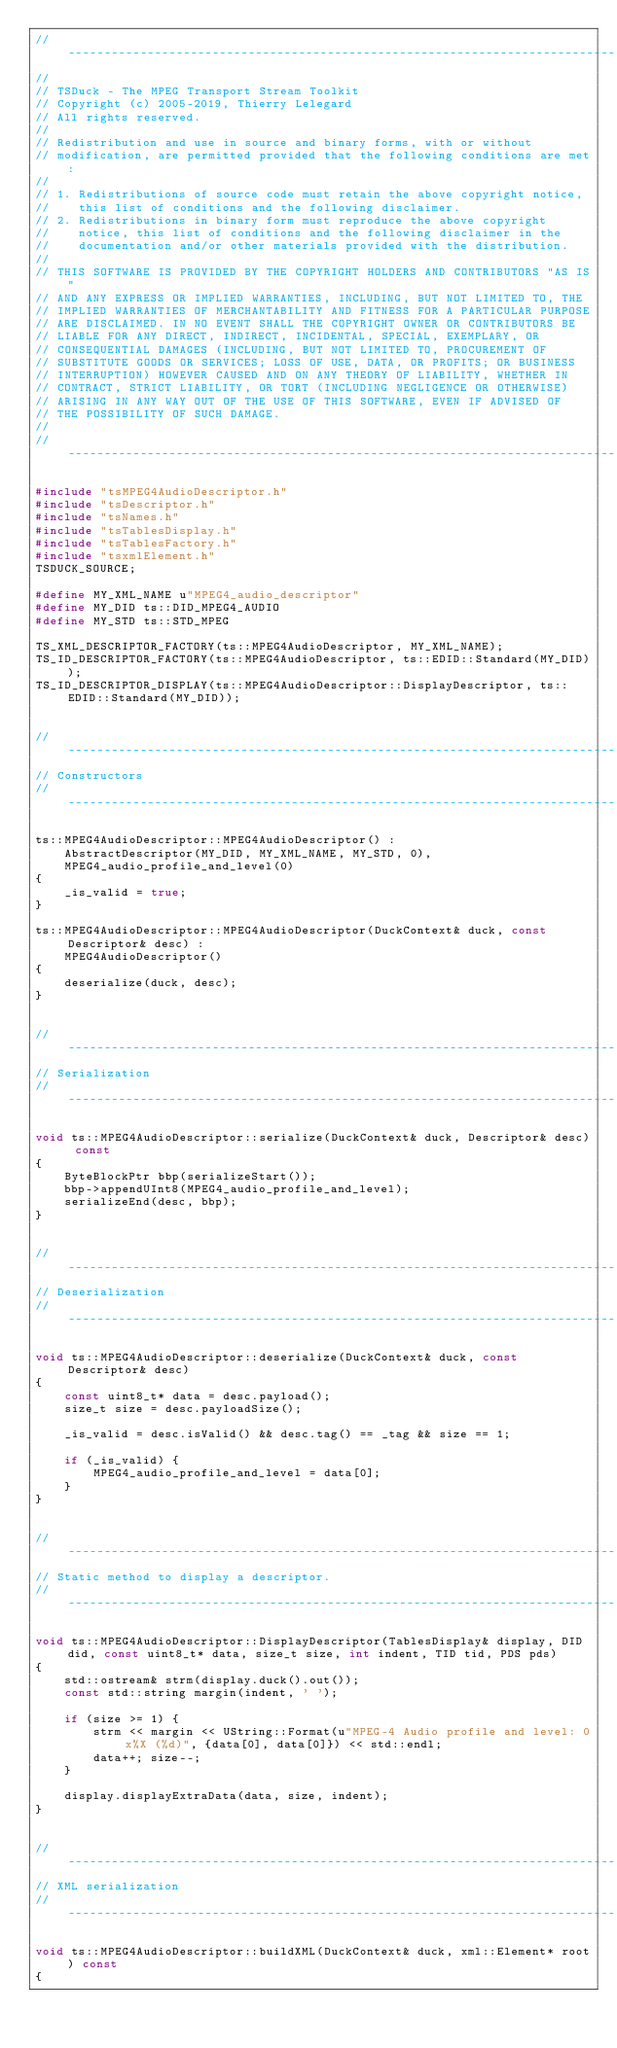<code> <loc_0><loc_0><loc_500><loc_500><_C++_>//----------------------------------------------------------------------------
//
// TSDuck - The MPEG Transport Stream Toolkit
// Copyright (c) 2005-2019, Thierry Lelegard
// All rights reserved.
//
// Redistribution and use in source and binary forms, with or without
// modification, are permitted provided that the following conditions are met:
//
// 1. Redistributions of source code must retain the above copyright notice,
//    this list of conditions and the following disclaimer.
// 2. Redistributions in binary form must reproduce the above copyright
//    notice, this list of conditions and the following disclaimer in the
//    documentation and/or other materials provided with the distribution.
//
// THIS SOFTWARE IS PROVIDED BY THE COPYRIGHT HOLDERS AND CONTRIBUTORS "AS IS"
// AND ANY EXPRESS OR IMPLIED WARRANTIES, INCLUDING, BUT NOT LIMITED TO, THE
// IMPLIED WARRANTIES OF MERCHANTABILITY AND FITNESS FOR A PARTICULAR PURPOSE
// ARE DISCLAIMED. IN NO EVENT SHALL THE COPYRIGHT OWNER OR CONTRIBUTORS BE
// LIABLE FOR ANY DIRECT, INDIRECT, INCIDENTAL, SPECIAL, EXEMPLARY, OR
// CONSEQUENTIAL DAMAGES (INCLUDING, BUT NOT LIMITED TO, PROCUREMENT OF
// SUBSTITUTE GOODS OR SERVICES; LOSS OF USE, DATA, OR PROFITS; OR BUSINESS
// INTERRUPTION) HOWEVER CAUSED AND ON ANY THEORY OF LIABILITY, WHETHER IN
// CONTRACT, STRICT LIABILITY, OR TORT (INCLUDING NEGLIGENCE OR OTHERWISE)
// ARISING IN ANY WAY OUT OF THE USE OF THIS SOFTWARE, EVEN IF ADVISED OF
// THE POSSIBILITY OF SUCH DAMAGE.
//
//----------------------------------------------------------------------------

#include "tsMPEG4AudioDescriptor.h"
#include "tsDescriptor.h"
#include "tsNames.h"
#include "tsTablesDisplay.h"
#include "tsTablesFactory.h"
#include "tsxmlElement.h"
TSDUCK_SOURCE;

#define MY_XML_NAME u"MPEG4_audio_descriptor"
#define MY_DID ts::DID_MPEG4_AUDIO
#define MY_STD ts::STD_MPEG

TS_XML_DESCRIPTOR_FACTORY(ts::MPEG4AudioDescriptor, MY_XML_NAME);
TS_ID_DESCRIPTOR_FACTORY(ts::MPEG4AudioDescriptor, ts::EDID::Standard(MY_DID));
TS_ID_DESCRIPTOR_DISPLAY(ts::MPEG4AudioDescriptor::DisplayDescriptor, ts::EDID::Standard(MY_DID));


//----------------------------------------------------------------------------
// Constructors
//----------------------------------------------------------------------------

ts::MPEG4AudioDescriptor::MPEG4AudioDescriptor() :
    AbstractDescriptor(MY_DID, MY_XML_NAME, MY_STD, 0),
    MPEG4_audio_profile_and_level(0)
{
    _is_valid = true;
}

ts::MPEG4AudioDescriptor::MPEG4AudioDescriptor(DuckContext& duck, const Descriptor& desc) :
    MPEG4AudioDescriptor()
{
    deserialize(duck, desc);
}


//----------------------------------------------------------------------------
// Serialization
//----------------------------------------------------------------------------

void ts::MPEG4AudioDescriptor::serialize(DuckContext& duck, Descriptor& desc) const
{
    ByteBlockPtr bbp(serializeStart());
    bbp->appendUInt8(MPEG4_audio_profile_and_level);
    serializeEnd(desc, bbp);
}


//----------------------------------------------------------------------------
// Deserialization
//----------------------------------------------------------------------------

void ts::MPEG4AudioDescriptor::deserialize(DuckContext& duck, const Descriptor& desc)
{
    const uint8_t* data = desc.payload();
    size_t size = desc.payloadSize();

    _is_valid = desc.isValid() && desc.tag() == _tag && size == 1;

    if (_is_valid) {
        MPEG4_audio_profile_and_level = data[0];
    }
}


//----------------------------------------------------------------------------
// Static method to display a descriptor.
//----------------------------------------------------------------------------

void ts::MPEG4AudioDescriptor::DisplayDescriptor(TablesDisplay& display, DID did, const uint8_t* data, size_t size, int indent, TID tid, PDS pds)
{
    std::ostream& strm(display.duck().out());
    const std::string margin(indent, ' ');

    if (size >= 1) {
        strm << margin << UString::Format(u"MPEG-4 Audio profile and level: 0x%X (%d)", {data[0], data[0]}) << std::endl;
        data++; size--;
    }

    display.displayExtraData(data, size, indent);
}


//----------------------------------------------------------------------------
// XML serialization
//----------------------------------------------------------------------------

void ts::MPEG4AudioDescriptor::buildXML(DuckContext& duck, xml::Element* root) const
{</code> 